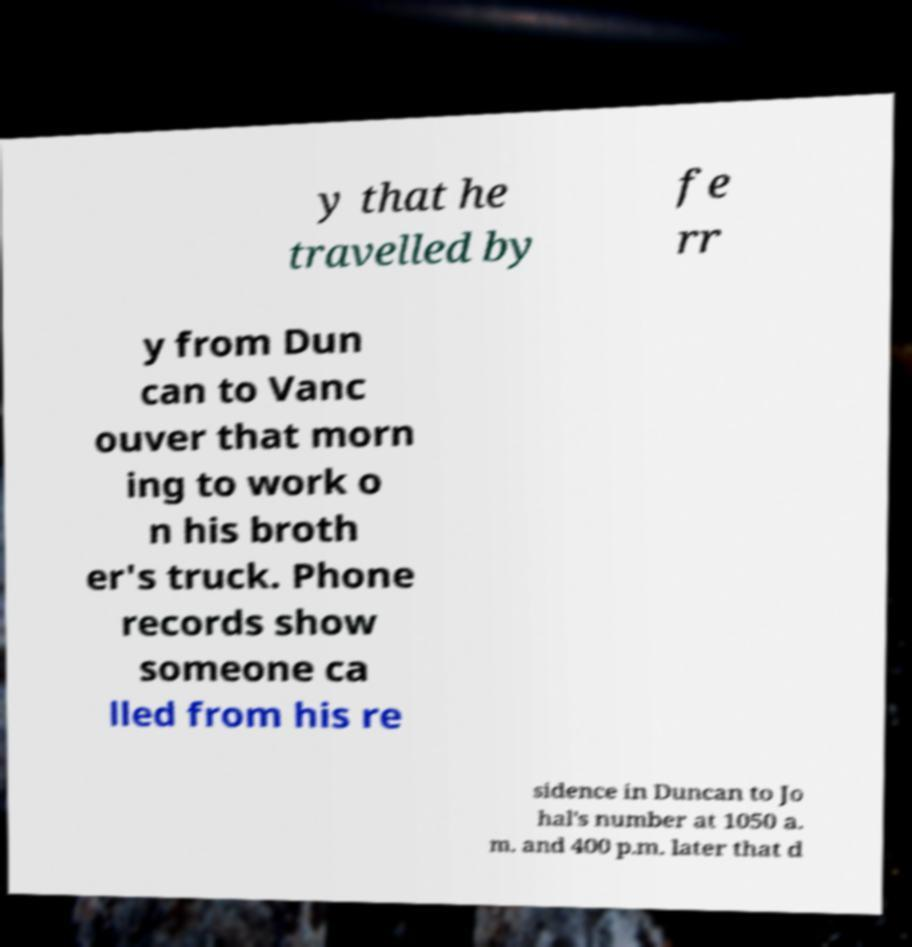Please read and relay the text visible in this image. What does it say? y that he travelled by fe rr y from Dun can to Vanc ouver that morn ing to work o n his broth er's truck. Phone records show someone ca lled from his re sidence in Duncan to Jo hal's number at 1050 a. m. and 400 p.m. later that d 